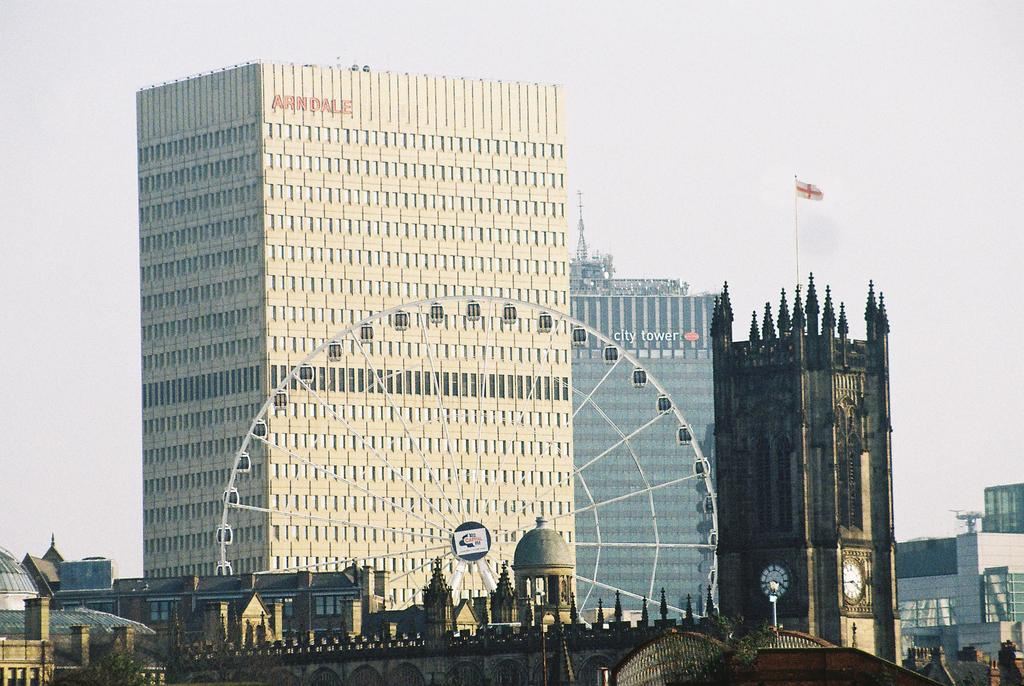What type of structures can be seen in the image? There are many buildings in the image. What amusement ride is present in the image? There is a giant wheel in the image. What type of transportation infrastructure is visible in the image? There is a bridge in the image. What type of clock is present in the image? There is a clock tower in the image. What is on top of the clock tower? There is a flag on top of the clock tower. What is the condition of the sky in the image? The sky is clear in the image. How does the airport cover the nerve of the city in the image? There is no airport present in the image, so it cannot cover any nerves of the city. 